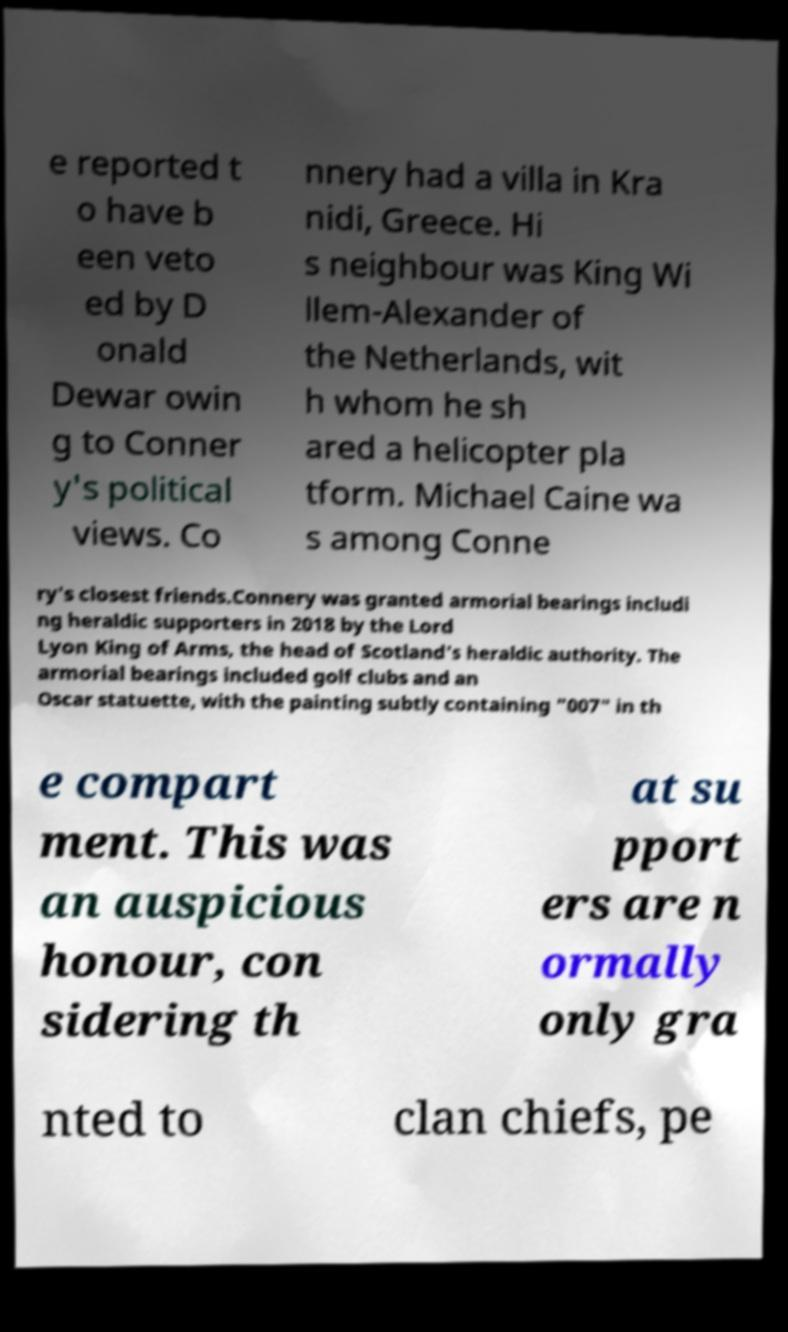What messages or text are displayed in this image? I need them in a readable, typed format. e reported t o have b een veto ed by D onald Dewar owin g to Conner y's political views. Co nnery had a villa in Kra nidi, Greece. Hi s neighbour was King Wi llem-Alexander of the Netherlands, wit h whom he sh ared a helicopter pla tform. Michael Caine wa s among Conne ry's closest friends.Connery was granted armorial bearings includi ng heraldic supporters in 2018 by the Lord Lyon King of Arms, the head of Scotland's heraldic authority. The armorial bearings included golf clubs and an Oscar statuette, with the painting subtly containing "007" in th e compart ment. This was an auspicious honour, con sidering th at su pport ers are n ormally only gra nted to clan chiefs, pe 